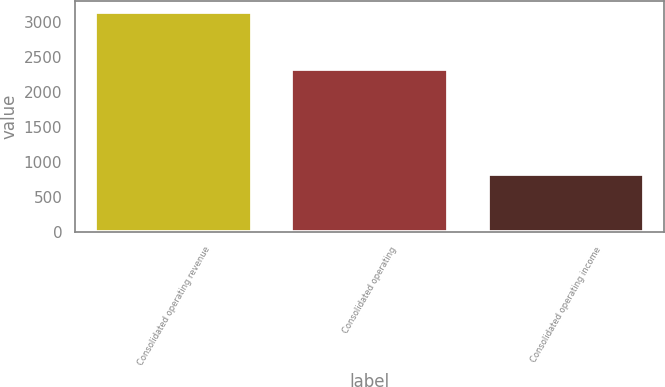Convert chart to OTSL. <chart><loc_0><loc_0><loc_500><loc_500><bar_chart><fcel>Consolidated operating revenue<fcel>Consolidated operating<fcel>Consolidated operating income<nl><fcel>3144.9<fcel>2327<fcel>817.9<nl></chart> 